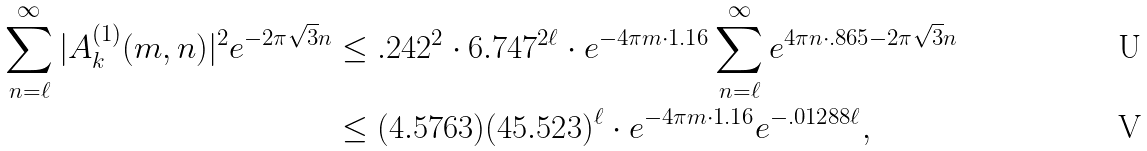<formula> <loc_0><loc_0><loc_500><loc_500>\sum _ { n = \ell } ^ { \infty } | A _ { k } ^ { ( 1 ) } ( m , n ) | ^ { 2 } e ^ { - 2 \pi \sqrt { 3 } n } & \leq . 2 4 2 ^ { 2 } \cdot 6 . 7 4 7 ^ { 2 \ell } \cdot e ^ { - 4 \pi m \cdot 1 . 1 6 } \sum _ { n = \ell } ^ { \infty } e ^ { 4 \pi n \cdot . 8 6 5 - 2 \pi \sqrt { 3 } n } \\ & \leq ( 4 . 5 7 6 3 ) ( 4 5 . 5 2 3 ) ^ { \ell } \cdot e ^ { - 4 \pi m \cdot 1 . 1 6 } e ^ { - . 0 1 2 8 8 \ell } ,</formula> 